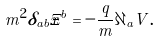Convert formula to latex. <formula><loc_0><loc_0><loc_500><loc_500>m ^ { 2 } \delta _ { a b } \ddot { x } ^ { b } = - \frac { q } { m } \partial _ { a } V .</formula> 